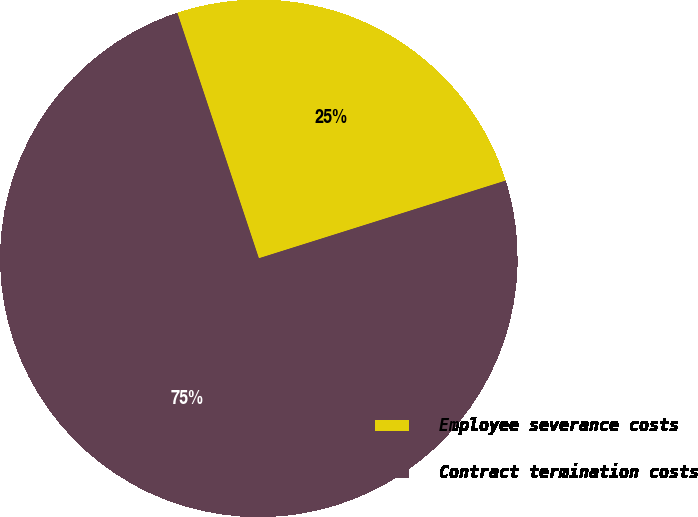<chart> <loc_0><loc_0><loc_500><loc_500><pie_chart><fcel>Employee severance costs<fcel>Contract termination costs<nl><fcel>25.25%<fcel>74.75%<nl></chart> 